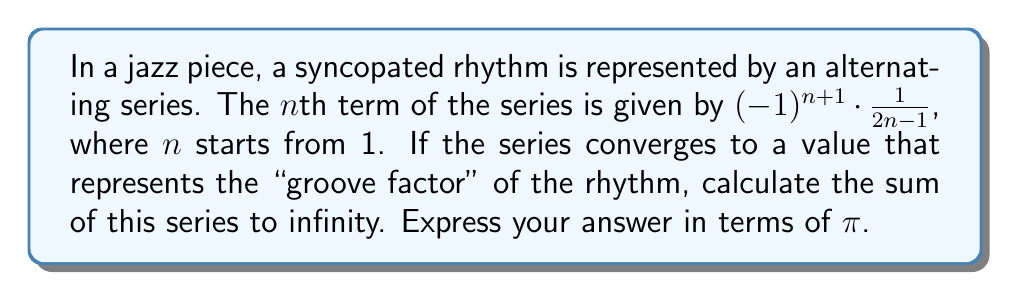Help me with this question. Let's approach this step-by-step:

1) First, we recognize that this is an alternating series in the form:

   $$ S = \sum_{n=1}^{\infty} (-1)^{n+1} \cdot \frac{1}{2n-1} $$

2) This series can be rewritten as:

   $$ S = 1 - \frac{1}{3} + \frac{1}{5} - \frac{1}{7} + \frac{1}{9} - ... $$

3) This is a well-known series in mathematics. It's the Maclaurin series for the arctangent function, specifically:

   $$ \arctan(x) = x - \frac{x^3}{3} + \frac{x^5}{5} - \frac{x^7}{7} + ... $$

4) Our series matches this when x = 1:

   $$ \arctan(1) = 1 - \frac{1}{3} + \frac{1}{5} - \frac{1}{7} + ... $$

5) We know that $\arctan(1) = \frac{\pi}{4}$, as this represents the angle of a 1-1-$\sqrt{2}$ right triangle.

Therefore, the sum of our series is equal to $\frac{\pi}{4}$.
Answer: $\frac{\pi}{4}$ 